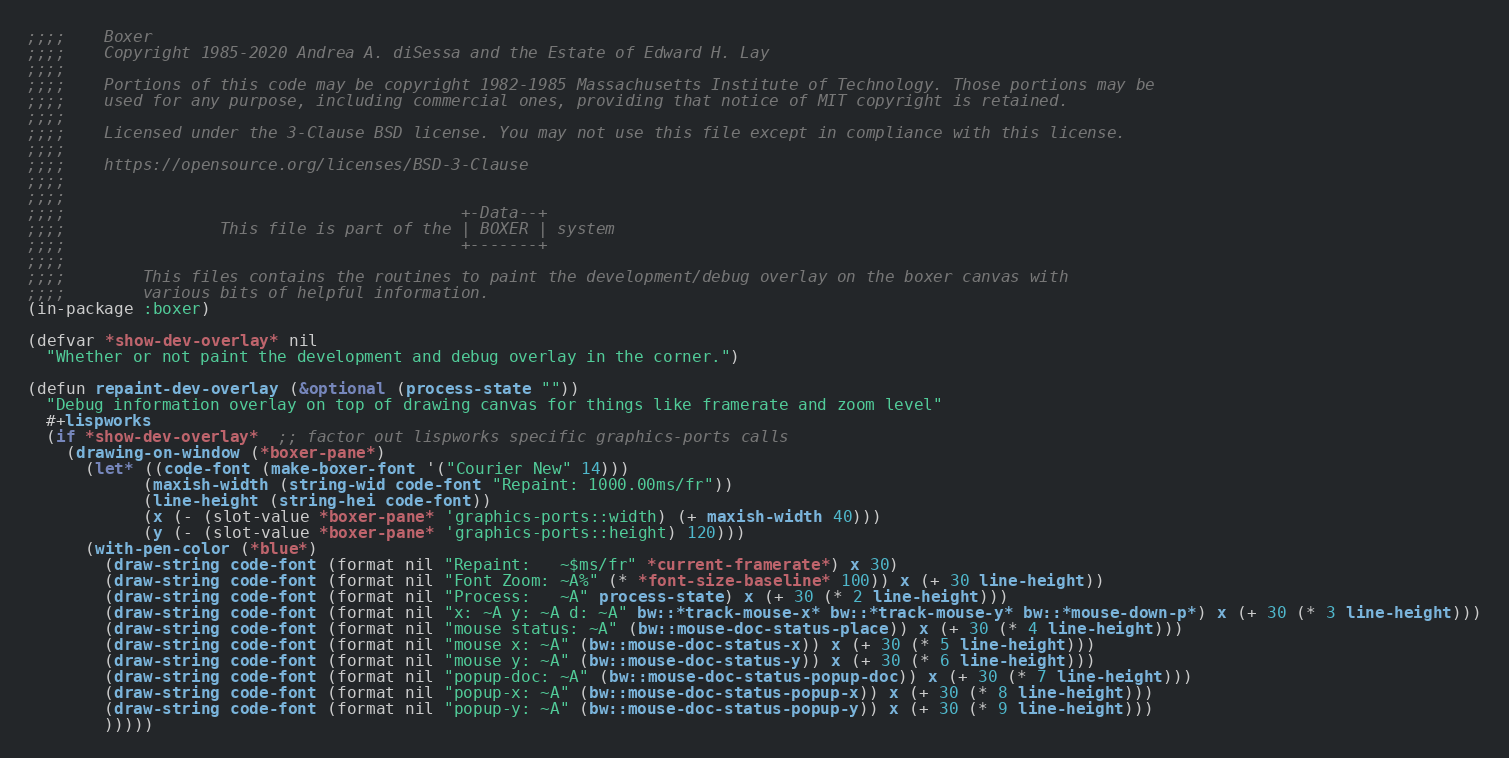Convert code to text. <code><loc_0><loc_0><loc_500><loc_500><_Lisp_>;;;;    Boxer
;;;;    Copyright 1985-2020 Andrea A. diSessa and the Estate of Edward H. Lay
;;;;
;;;;    Portions of this code may be copyright 1982-1985 Massachusetts Institute of Technology. Those portions may be
;;;;    used for any purpose, including commercial ones, providing that notice of MIT copyright is retained.
;;;;
;;;;    Licensed under the 3-Clause BSD license. You may not use this file except in compliance with this license.
;;;;
;;;;    https://opensource.org/licenses/BSD-3-Clause
;;;;
;;;;
;;;;                                         +-Data--+
;;;;                This file is part of the | BOXER | system
;;;;                                         +-------+
;;;;
;;;;        This files contains the routines to paint the development/debug overlay on the boxer canvas with
;;;;        various bits of helpful information.
(in-package :boxer)

(defvar *show-dev-overlay* nil
  "Whether or not paint the development and debug overlay in the corner.")

(defun repaint-dev-overlay (&optional (process-state ""))
  "Debug information overlay on top of drawing canvas for things like framerate and zoom level"
  #+lispworks
  (if *show-dev-overlay*  ;; factor out lispworks specific graphics-ports calls
    (drawing-on-window (*boxer-pane*)
      (let* ((code-font (make-boxer-font '("Courier New" 14)))
            (maxish-width (string-wid code-font "Repaint: 1000.00ms/fr"))
            (line-height (string-hei code-font))
            (x (- (slot-value *boxer-pane* 'graphics-ports::width) (+ maxish-width 40)))
            (y (- (slot-value *boxer-pane* 'graphics-ports::height) 120)))
      (with-pen-color (*blue*)
        (draw-string code-font (format nil "Repaint:   ~$ms/fr" *current-framerate*) x 30)
        (draw-string code-font (format nil "Font Zoom: ~A%" (* *font-size-baseline* 100)) x (+ 30 line-height))
        (draw-string code-font (format nil "Process:   ~A" process-state) x (+ 30 (* 2 line-height)))
        (draw-string code-font (format nil "x: ~A y: ~A d: ~A" bw::*track-mouse-x* bw::*track-mouse-y* bw::*mouse-down-p*) x (+ 30 (* 3 line-height)))
        (draw-string code-font (format nil "mouse status: ~A" (bw::mouse-doc-status-place)) x (+ 30 (* 4 line-height)))
        (draw-string code-font (format nil "mouse x: ~A" (bw::mouse-doc-status-x)) x (+ 30 (* 5 line-height)))
        (draw-string code-font (format nil "mouse y: ~A" (bw::mouse-doc-status-y)) x (+ 30 (* 6 line-height)))
        (draw-string code-font (format nil "popup-doc: ~A" (bw::mouse-doc-status-popup-doc)) x (+ 30 (* 7 line-height)))
        (draw-string code-font (format nil "popup-x: ~A" (bw::mouse-doc-status-popup-x)) x (+ 30 (* 8 line-height)))
        (draw-string code-font (format nil "popup-y: ~A" (bw::mouse-doc-status-popup-y)) x (+ 30 (* 9 line-height)))
        )))))
</code> 